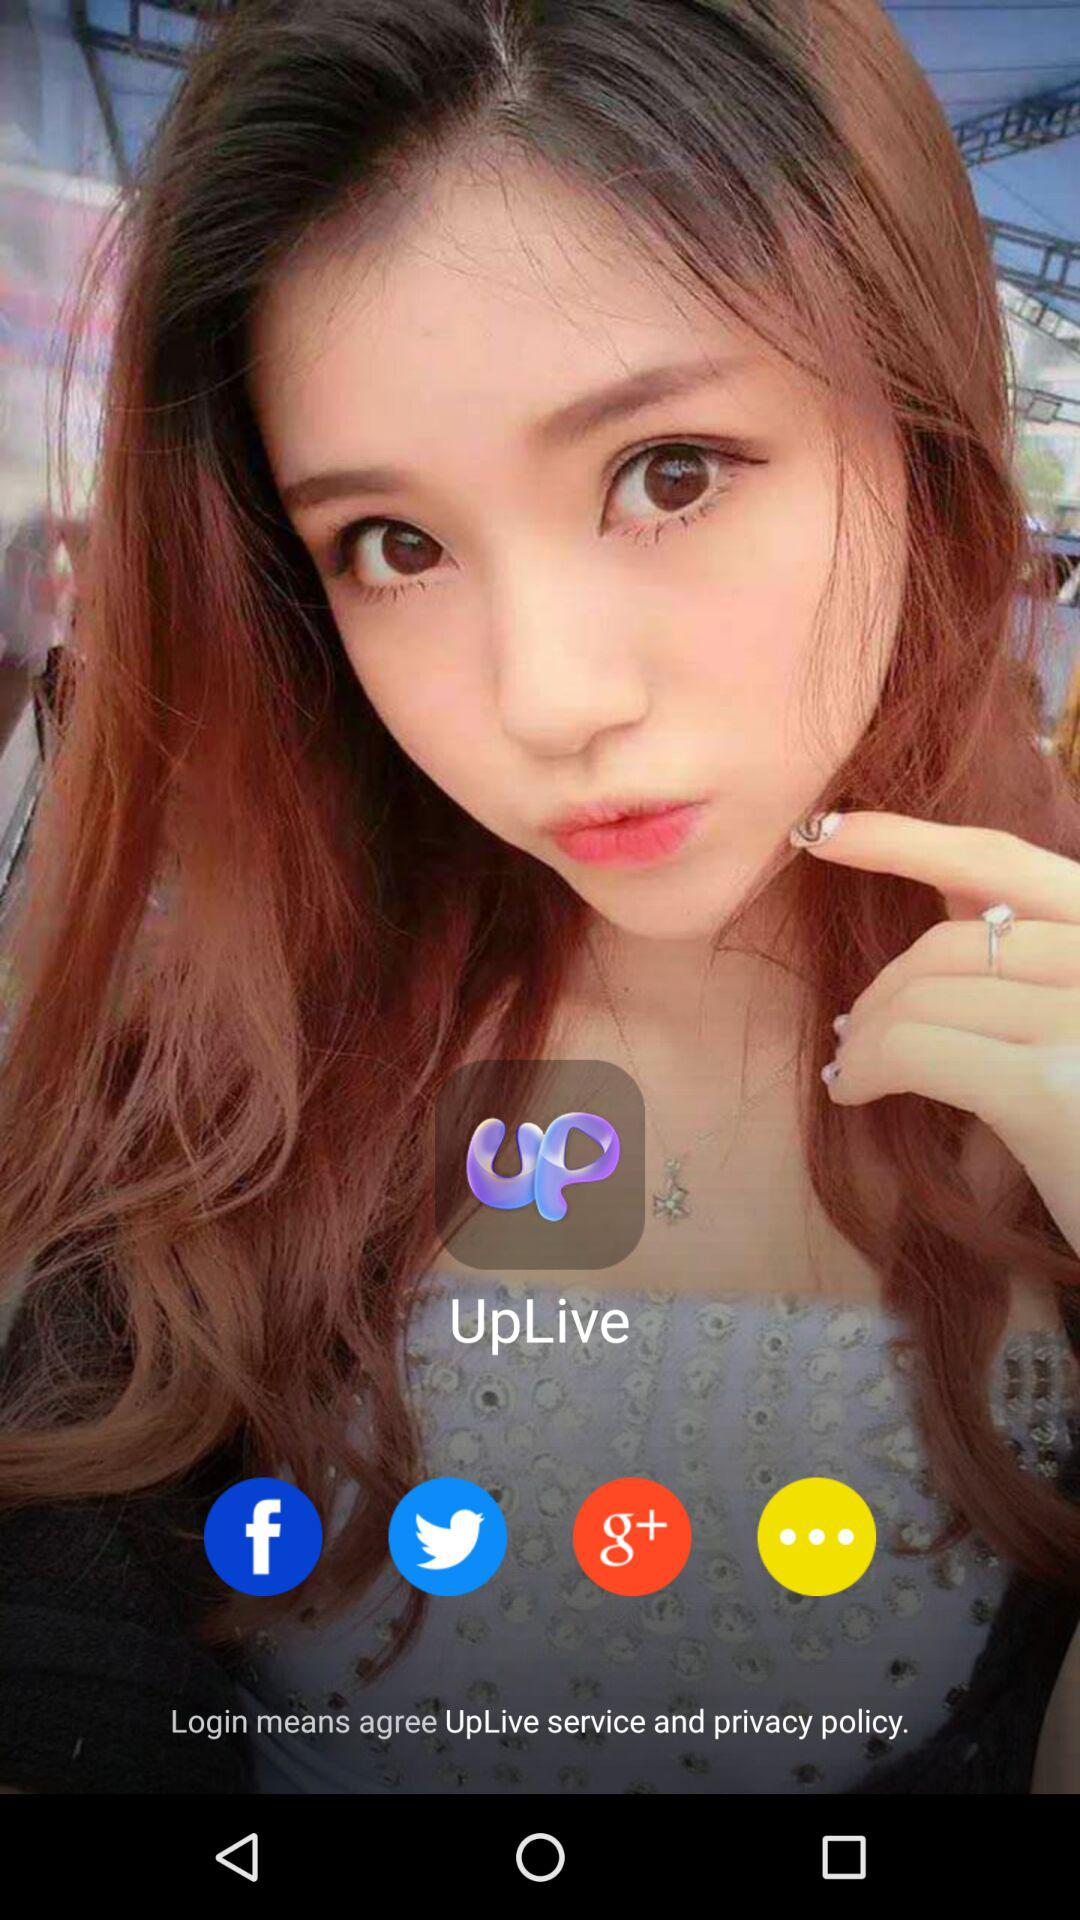What is the name of the application? The name of the application is "UpLive". 